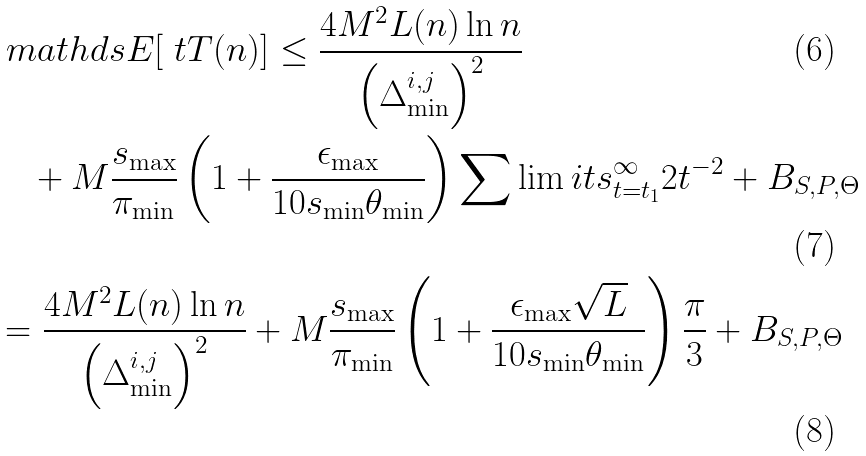Convert formula to latex. <formula><loc_0><loc_0><loc_500><loc_500>& \ m a t h d s { E } [ \ t T ( n ) ] \leq \frac { 4 M ^ { 2 } L ( n ) \ln n } { \left ( \Delta _ { \min } ^ { i , j } \right ) ^ { 2 } } \\ & \quad + M \frac { s _ { \max } } { \pi _ { \min } } \left ( 1 + \frac { \epsilon _ { \max } } { 1 0 s _ { \min } \theta _ { \min } } \right ) \sum \lim i t s _ { t = t _ { 1 } } ^ { \infty } 2 t ^ { - 2 } + B _ { S , P , \Theta } \\ & = \frac { 4 M ^ { 2 } L ( n ) \ln n } { \left ( \Delta _ { \min } ^ { i , j } \right ) ^ { 2 } } + M \frac { s _ { \max } } { \pi _ { \min } } \left ( 1 + \frac { \epsilon _ { \max } \sqrt { L } } { 1 0 s _ { \min } \theta _ { \min } } \right ) \frac { \pi } { 3 } + B _ { S , P , \Theta }</formula> 